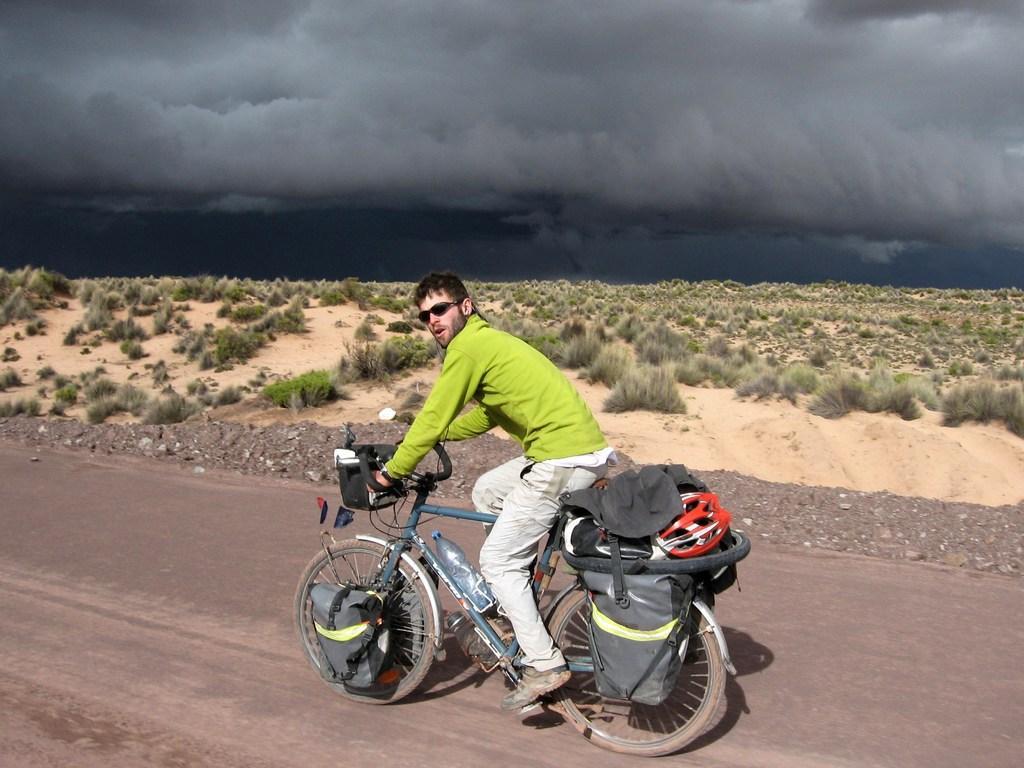Describe this image in one or two sentences. As we can see in the image there is a sky, grass, bag and a man riding bicycle. 